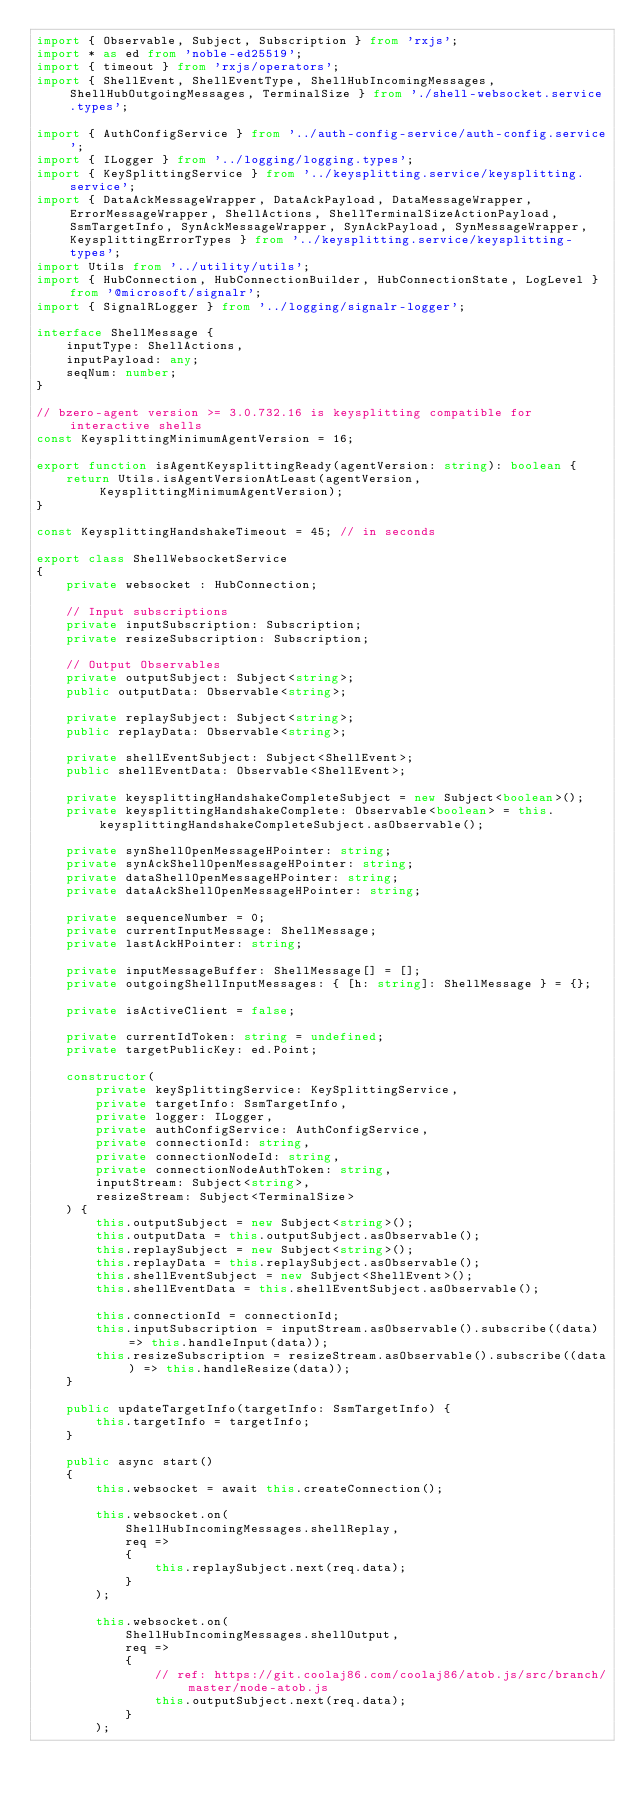<code> <loc_0><loc_0><loc_500><loc_500><_TypeScript_>import { Observable, Subject, Subscription } from 'rxjs';
import * as ed from 'noble-ed25519';
import { timeout } from 'rxjs/operators';
import { ShellEvent, ShellEventType, ShellHubIncomingMessages, ShellHubOutgoingMessages, TerminalSize } from './shell-websocket.service.types';

import { AuthConfigService } from '../auth-config-service/auth-config.service';
import { ILogger } from '../logging/logging.types';
import { KeySplittingService } from '../keysplitting.service/keysplitting.service';
import { DataAckMessageWrapper, DataAckPayload, DataMessageWrapper, ErrorMessageWrapper, ShellActions, ShellTerminalSizeActionPayload, SsmTargetInfo, SynAckMessageWrapper, SynAckPayload, SynMessageWrapper, KeysplittingErrorTypes } from '../keysplitting.service/keysplitting-types';
import Utils from '../utility/utils';
import { HubConnection, HubConnectionBuilder, HubConnectionState, LogLevel } from '@microsoft/signalr';
import { SignalRLogger } from '../logging/signalr-logger';

interface ShellMessage {
    inputType: ShellActions,
    inputPayload: any;
    seqNum: number;
}

// bzero-agent version >= 3.0.732.16 is keysplitting compatible for interactive shells
const KeysplittingMinimumAgentVersion = 16;

export function isAgentKeysplittingReady(agentVersion: string): boolean {
    return Utils.isAgentVersionAtLeast(agentVersion, KeysplittingMinimumAgentVersion);
}

const KeysplittingHandshakeTimeout = 45; // in seconds

export class ShellWebsocketService
{
    private websocket : HubConnection;

    // Input subscriptions
    private inputSubscription: Subscription;
    private resizeSubscription: Subscription;

    // Output Observables
    private outputSubject: Subject<string>;
    public outputData: Observable<string>;

    private replaySubject: Subject<string>;
    public replayData: Observable<string>;

    private shellEventSubject: Subject<ShellEvent>;
    public shellEventData: Observable<ShellEvent>;

    private keysplittingHandshakeCompleteSubject = new Subject<boolean>();
    private keysplittingHandshakeComplete: Observable<boolean> = this.keysplittingHandshakeCompleteSubject.asObservable();

    private synShellOpenMessageHPointer: string;
    private synAckShellOpenMessageHPointer: string;
    private dataShellOpenMessageHPointer: string;
    private dataAckShellOpenMessageHPointer: string;

    private sequenceNumber = 0;
    private currentInputMessage: ShellMessage;
    private lastAckHPointer: string;

    private inputMessageBuffer: ShellMessage[] = [];
    private outgoingShellInputMessages: { [h: string]: ShellMessage } = {};

    private isActiveClient = false;

    private currentIdToken: string = undefined;
    private targetPublicKey: ed.Point;

    constructor(
        private keySplittingService: KeySplittingService,
        private targetInfo: SsmTargetInfo,
        private logger: ILogger,
        private authConfigService: AuthConfigService,
        private connectionId: string,
        private connectionNodeId: string,
        private connectionNodeAuthToken: string,
        inputStream: Subject<string>,
        resizeStream: Subject<TerminalSize>
    ) {
        this.outputSubject = new Subject<string>();
        this.outputData = this.outputSubject.asObservable();
        this.replaySubject = new Subject<string>();
        this.replayData = this.replaySubject.asObservable();
        this.shellEventSubject = new Subject<ShellEvent>();
        this.shellEventData = this.shellEventSubject.asObservable();

        this.connectionId = connectionId;
        this.inputSubscription = inputStream.asObservable().subscribe((data) => this.handleInput(data));
        this.resizeSubscription = resizeStream.asObservable().subscribe((data) => this.handleResize(data));
    }

    public updateTargetInfo(targetInfo: SsmTargetInfo) {
        this.targetInfo = targetInfo;
    }

    public async start()
    {
        this.websocket = await this.createConnection();

        this.websocket.on(
            ShellHubIncomingMessages.shellReplay,
            req =>
            {
                this.replaySubject.next(req.data);
            }
        );

        this.websocket.on(
            ShellHubIncomingMessages.shellOutput,
            req =>
            {
                // ref: https://git.coolaj86.com/coolaj86/atob.js/src/branch/master/node-atob.js
                this.outputSubject.next(req.data);
            }
        );
</code> 